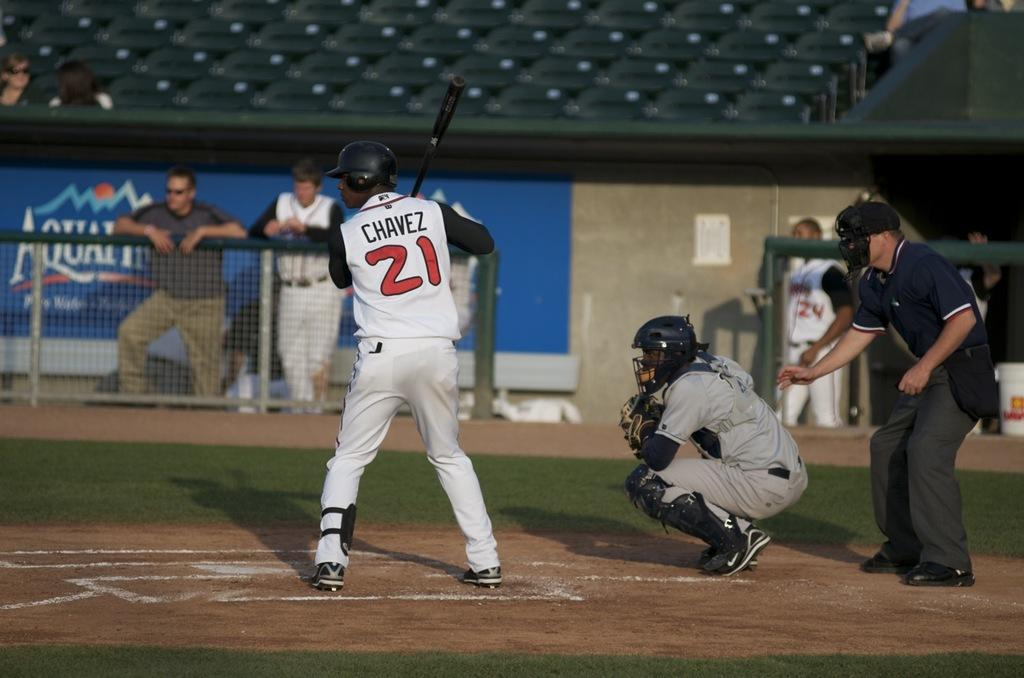Provide a one-sentence caption for the provided image. A baseball player at bat in a 21 jersey. 